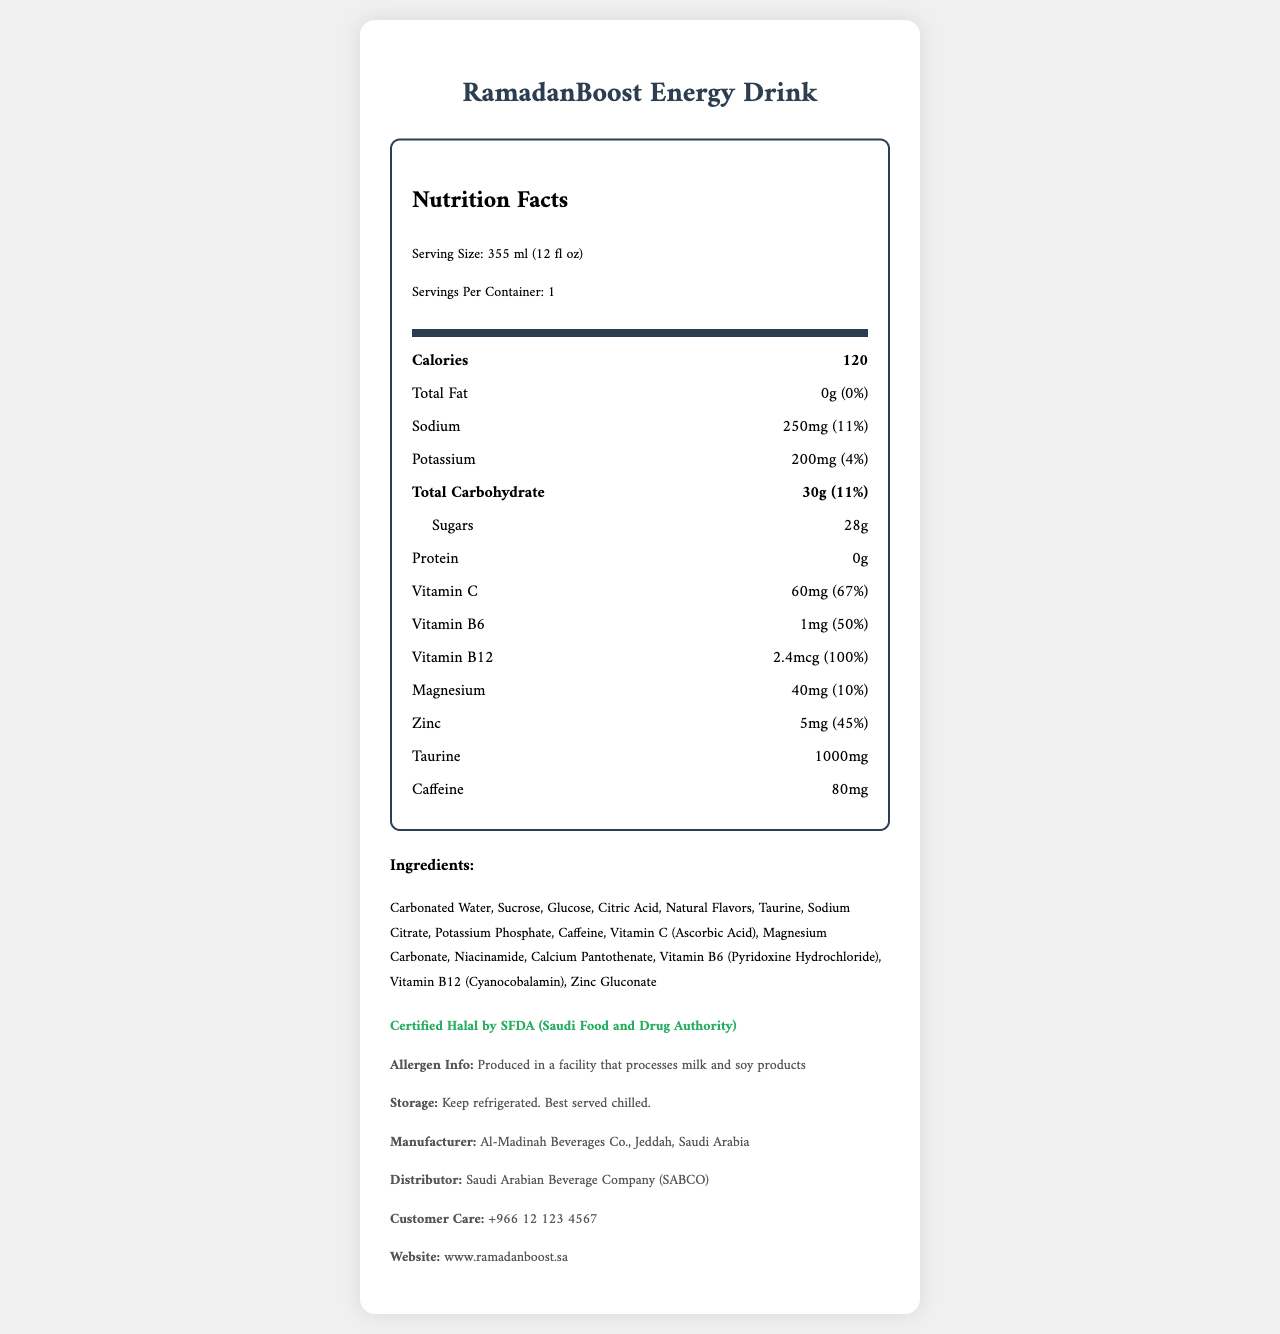what is the serving size of RamadanBoost Energy Drink? The serving size is stated in the document as 355 ml (12 fl oz).
Answer: 355 ml (12 fl oz) how much sodium does one serving contain? The document lists the sodium content as 250mg.
Answer: 250mg what is the amount of potassium per serving? The potassium content per serving is mentioned as 200mg.
Answer: 200mg how many grams of sugars are in a serving? The document states that there are 28 grams of sugars per serving.
Answer: 28g what is the percentage daily value of carbohydrates? The percentage daily value for carbohydrates is given as 11%.
Answer: 11% which vitamins are included in RamadanBoost Energy Drink? The document lists Vitamin C, Vitamin B6, and Vitamin B12.
Answer: Vitamin C, Vitamin B6, Vitamin B12 is the product certified Halal? The document specifies that the product is Certified Halal by SFDA (Saudi Food and Drug Authority).
Answer: Yes which of the following is the caffeine content in RamadanBoost Energy Drink? 
A. 40mg 
B. 60mg 
C. 80mg 
D. 100mg The document lists the caffeine content as 80mg.
Answer: C which ingredient is not found in RamadanBoost Energy Drink? 
A. Sucrose 
B. Aspartame 
C. Glucose 
D. Citric Acid Aspartame is not listed in the ingredients; Sucrose, Glucose, and Citric Acid are listed.
Answer: B how much protein does RamadanBoost Energy Drink contain? The document specifies that there is 0g of protein.
Answer: 0g list the minerals found in the energy drink. The minerals listed in the document are Sodium, Potassium, Magnesium, and Zinc.
Answer: Sodium, Potassium, Magnesium, Zinc describe the main idea of the document. The document is focused on presenting all relevant facts regarding the nutritional composition and other important details about the energy drink.
Answer: The document provides detailed nutritional information about RamadanBoost Energy Drink, including serving size, calorie content, vitamins, minerals, ingredients, halal certification, and manufacturer details. what is the total amount of taurine present in the drink? The document states that the drink contains 1000mg of taurine.
Answer: 1000mg what are the storage instructions for RamadanBoost Energy Drink? The storage instructions provided in the document are to keep the drink refrigerated and best served chilled.
Answer: Keep refrigerated. Best served chilled. is the product free from allergens? The document mentions that the product is produced in a facility that processes milk and soy products, indicating potential allergens.
Answer: No what is the vitamin B6 content as a percentage of daily value? The document lists Vitamin B6 content as 50% of the daily value.
Answer: 50% can we determine the exact caffeine source used in the drink? The document provides the caffeine content but does not specify the exact source of the caffeine.
Answer: Not enough information who is the manufacturer of RamadanBoost Energy Drink? According to the document, the manufacturer is Al-Madinah Beverages Co., Jeddah, Saudi Arabia.
Answer: Al-Madinah Beverages Co., Jeddah, Saudi Arabia what is the recommended way to consume RamadanBoost Energy Drink for optimal taste? The document states that the drink is best served chilled.
Answer: Chilled 